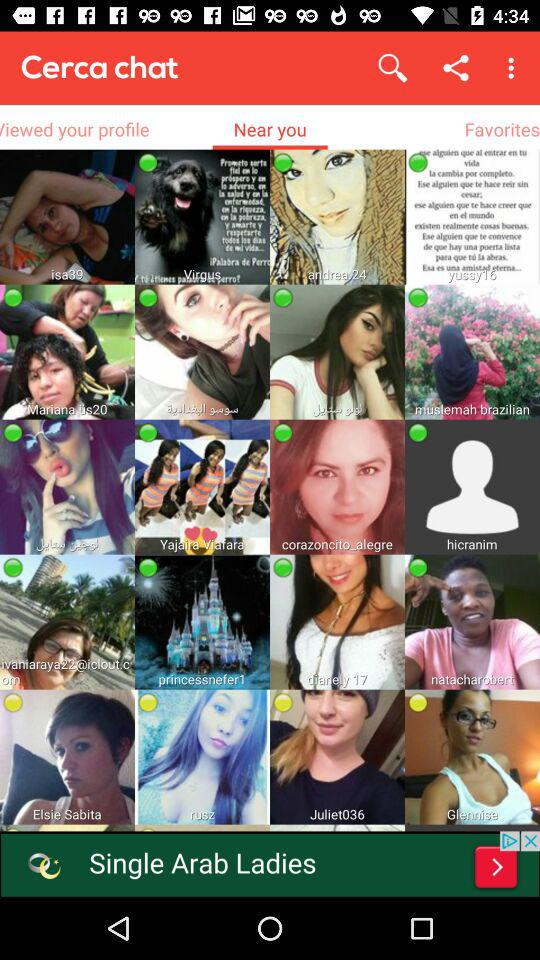What is the status of Elsie Sabita? The status of Elsie Sabita is "Idle". 